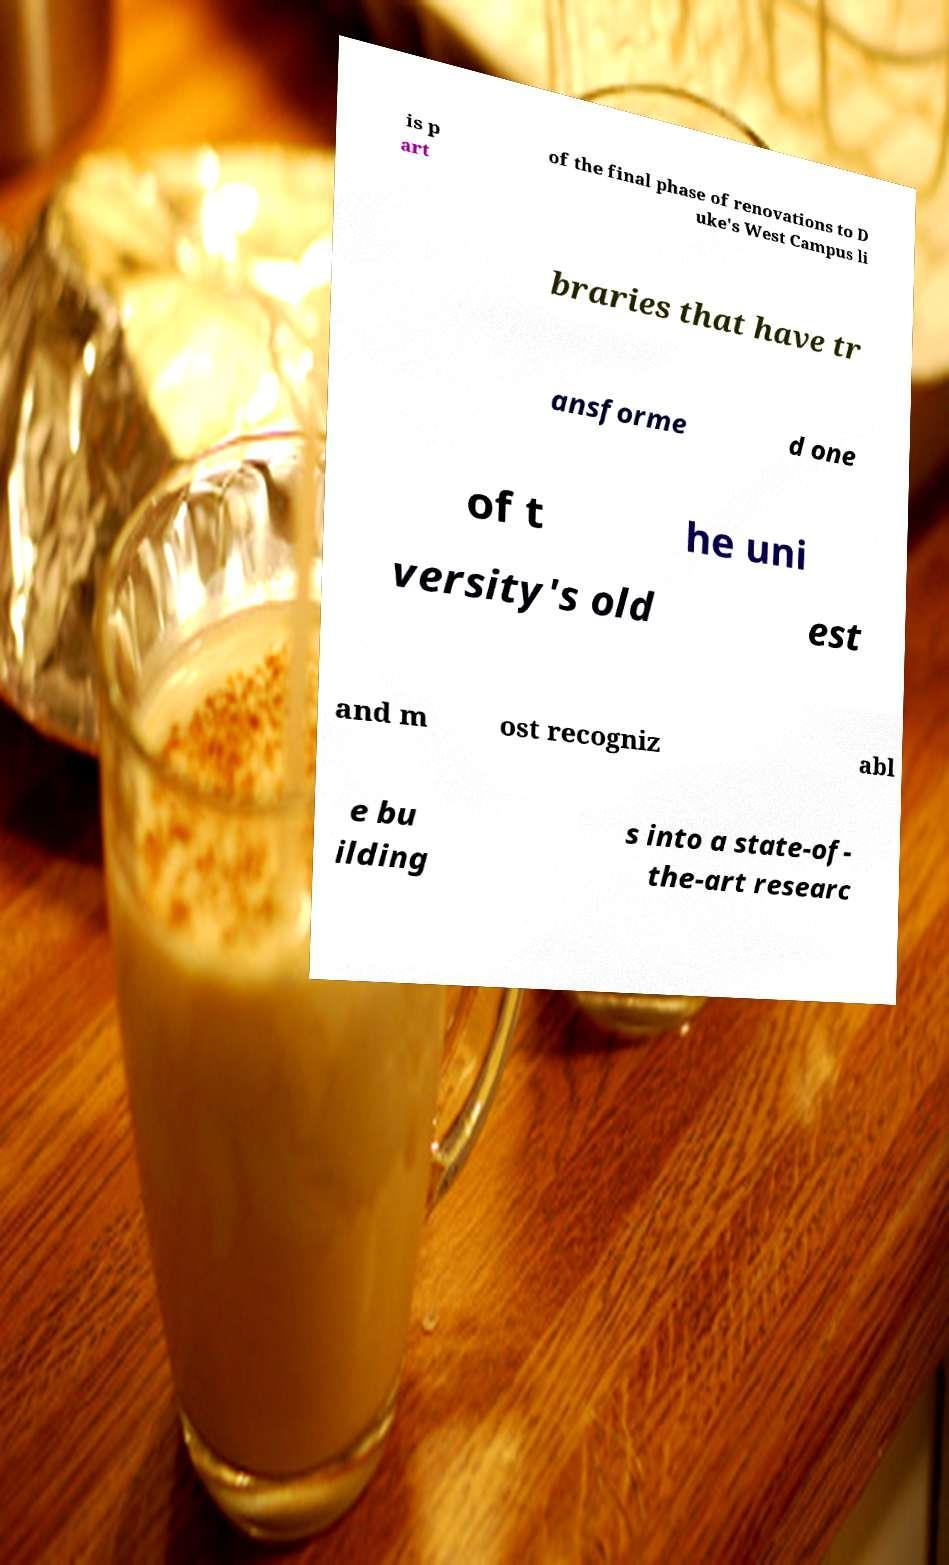Could you assist in decoding the text presented in this image and type it out clearly? is p art of the final phase of renovations to D uke's West Campus li braries that have tr ansforme d one of t he uni versity's old est and m ost recogniz abl e bu ilding s into a state-of- the-art researc 